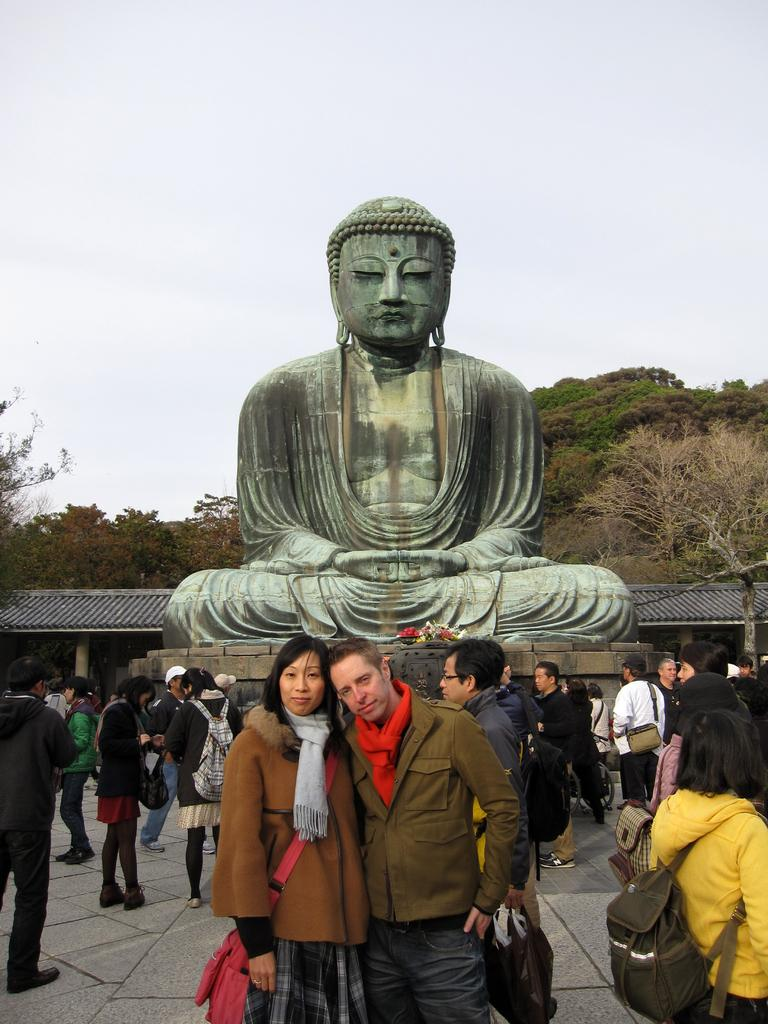How many people are in the image? There is a group of people in the image. What are the people doing in the image? The people are standing on a path. What can be seen in the background of the image? There is a statue and trees visible in the background, as well as the sky. What type of breakfast is being served to the visitors in the image? There is no mention of visitors or breakfast in the image; it features a group of people standing on a path with a statue, trees, and the sky visible in the background. 